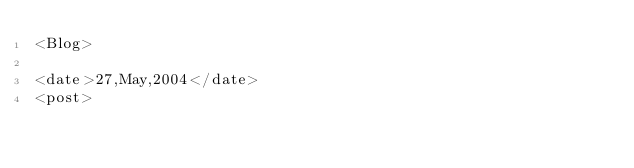Convert code to text. <code><loc_0><loc_0><loc_500><loc_500><_XML_><Blog>

<date>27,May,2004</date>
<post>

	 </code> 